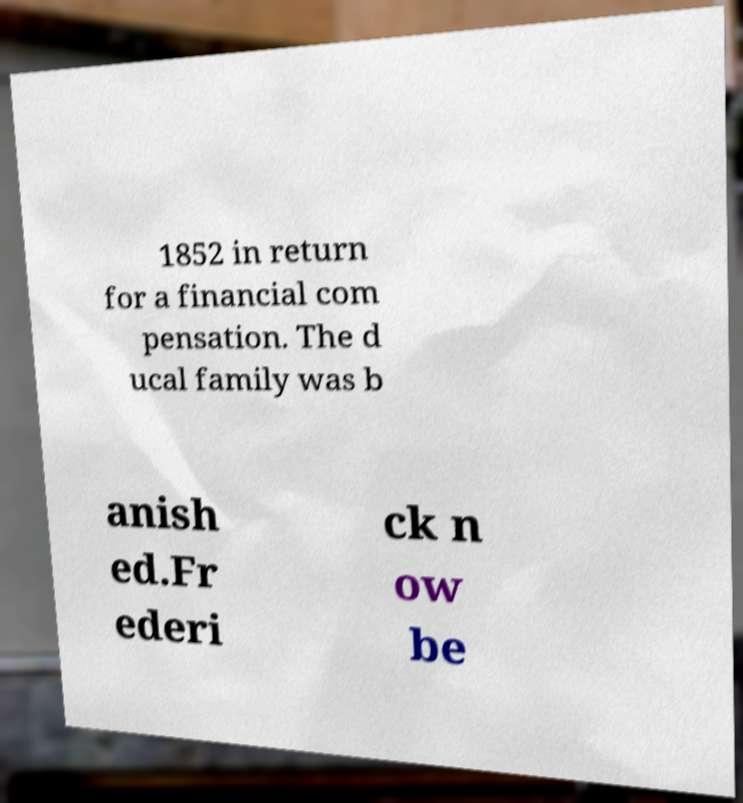Please read and relay the text visible in this image. What does it say? 1852 in return for a financial com pensation. The d ucal family was b anish ed.Fr ederi ck n ow be 